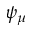Convert formula to latex. <formula><loc_0><loc_0><loc_500><loc_500>\psi _ { \mu }</formula> 